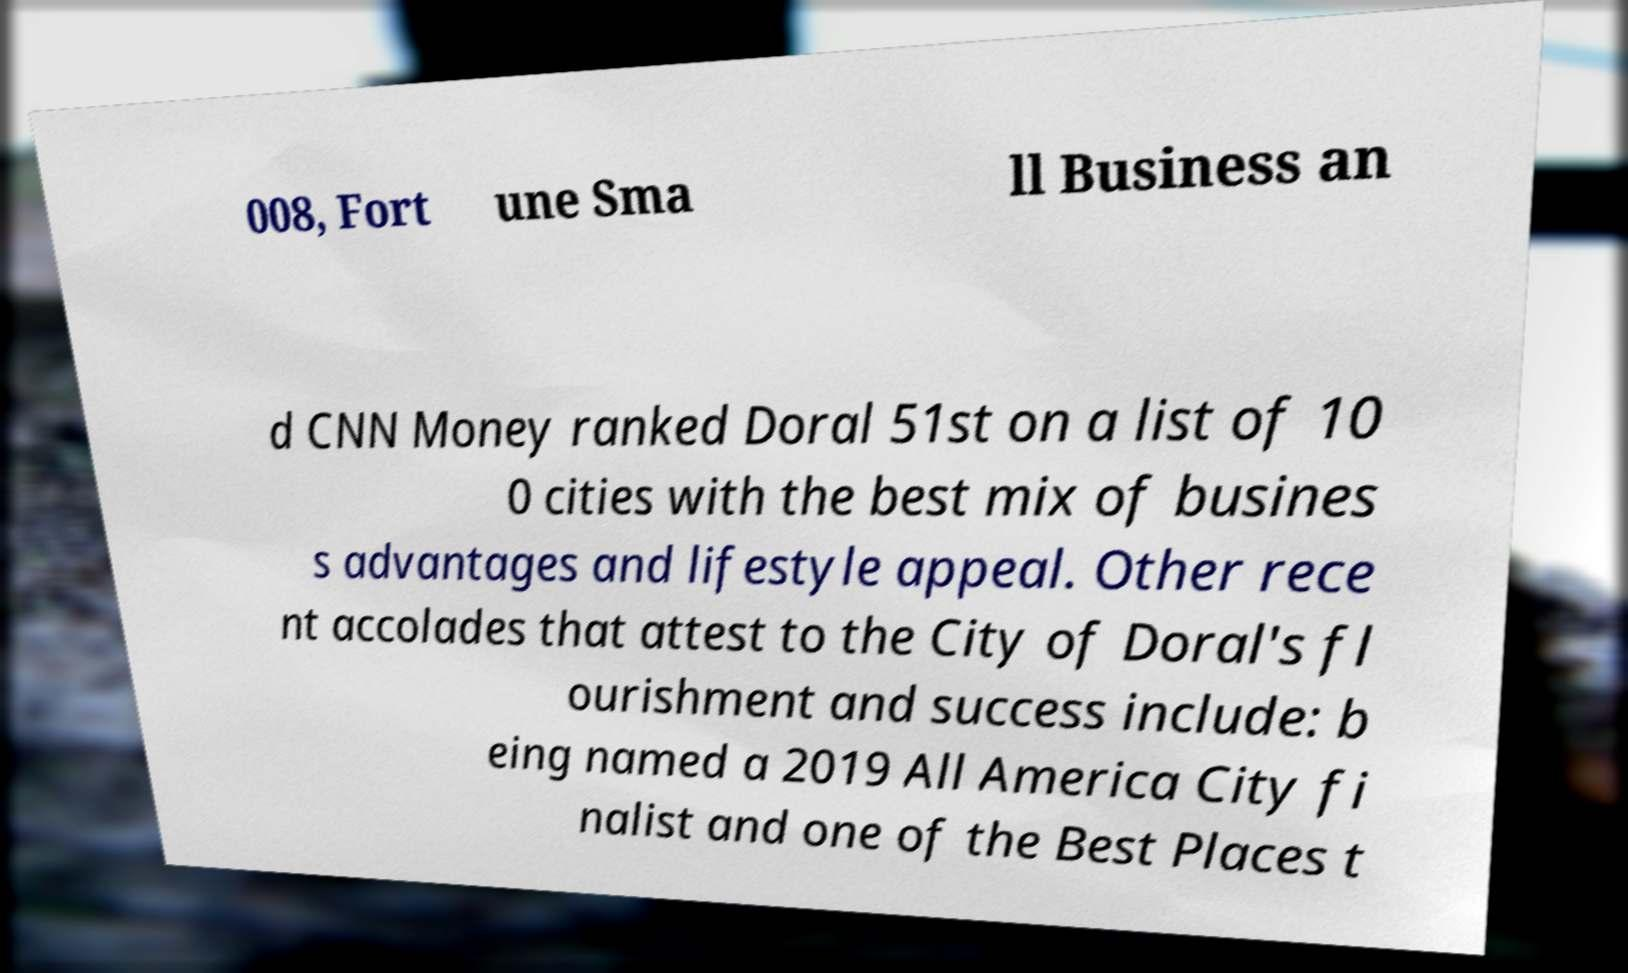Please identify and transcribe the text found in this image. 008, Fort une Sma ll Business an d CNN Money ranked Doral 51st on a list of 10 0 cities with the best mix of busines s advantages and lifestyle appeal. Other rece nt accolades that attest to the City of Doral's fl ourishment and success include: b eing named a 2019 All America City fi nalist and one of the Best Places t 